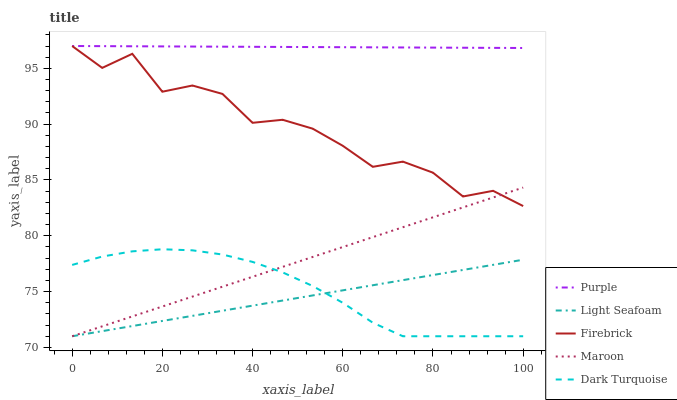Does Light Seafoam have the minimum area under the curve?
Answer yes or no. Yes. Does Purple have the maximum area under the curve?
Answer yes or no. Yes. Does Dark Turquoise have the minimum area under the curve?
Answer yes or no. No. Does Dark Turquoise have the maximum area under the curve?
Answer yes or no. No. Is Purple the smoothest?
Answer yes or no. Yes. Is Firebrick the roughest?
Answer yes or no. Yes. Is Dark Turquoise the smoothest?
Answer yes or no. No. Is Dark Turquoise the roughest?
Answer yes or no. No. Does Dark Turquoise have the lowest value?
Answer yes or no. Yes. Does Firebrick have the lowest value?
Answer yes or no. No. Does Firebrick have the highest value?
Answer yes or no. Yes. Does Dark Turquoise have the highest value?
Answer yes or no. No. Is Dark Turquoise less than Purple?
Answer yes or no. Yes. Is Firebrick greater than Dark Turquoise?
Answer yes or no. Yes. Does Light Seafoam intersect Maroon?
Answer yes or no. Yes. Is Light Seafoam less than Maroon?
Answer yes or no. No. Is Light Seafoam greater than Maroon?
Answer yes or no. No. Does Dark Turquoise intersect Purple?
Answer yes or no. No. 